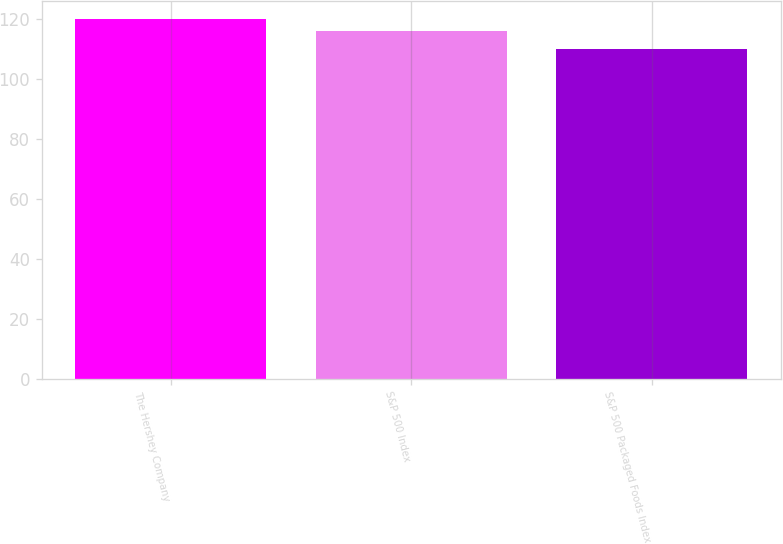<chart> <loc_0><loc_0><loc_500><loc_500><bar_chart><fcel>The Hershey Company<fcel>S&P 500 Index<fcel>S&P 500 Packaged Foods Index<nl><fcel>120<fcel>116<fcel>110<nl></chart> 